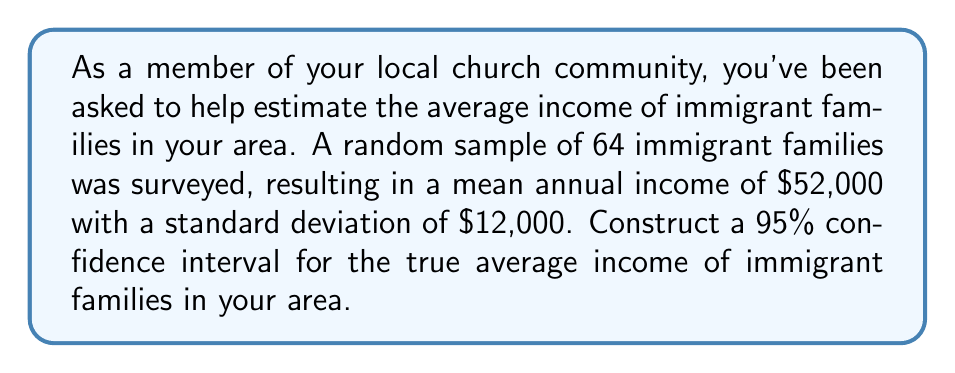What is the answer to this math problem? Let's approach this step-by-step:

1) We are given:
   - Sample size: $n = 64$
   - Sample mean: $\bar{x} = \$52,000$
   - Sample standard deviation: $s = \$12,000$
   - Confidence level: 95%

2) For a 95% confidence interval, we use a z-score of 1.96 (assuming normal distribution).

3) The formula for the confidence interval is:

   $$\bar{x} \pm z \frac{s}{\sqrt{n}}$$

4) Let's calculate the margin of error:

   $$\text{Margin of Error} = z \frac{s}{\sqrt{n}} = 1.96 \frac{12000}{\sqrt{64}} = 1.96 \frac{12000}{8} = 1.96 \times 1500 = 2940$$

5) Now, we can construct the confidence interval:

   Lower bound: $52000 - 2940 = 49060$
   Upper bound: $52000 + 2940 = 54940$

6) Therefore, the 95% confidence interval is ($49060, $54940).

This means we can be 95% confident that the true average income of immigrant families in the area falls between $49,060 and $54,940.
Answer: ($49,060, $54,940) 